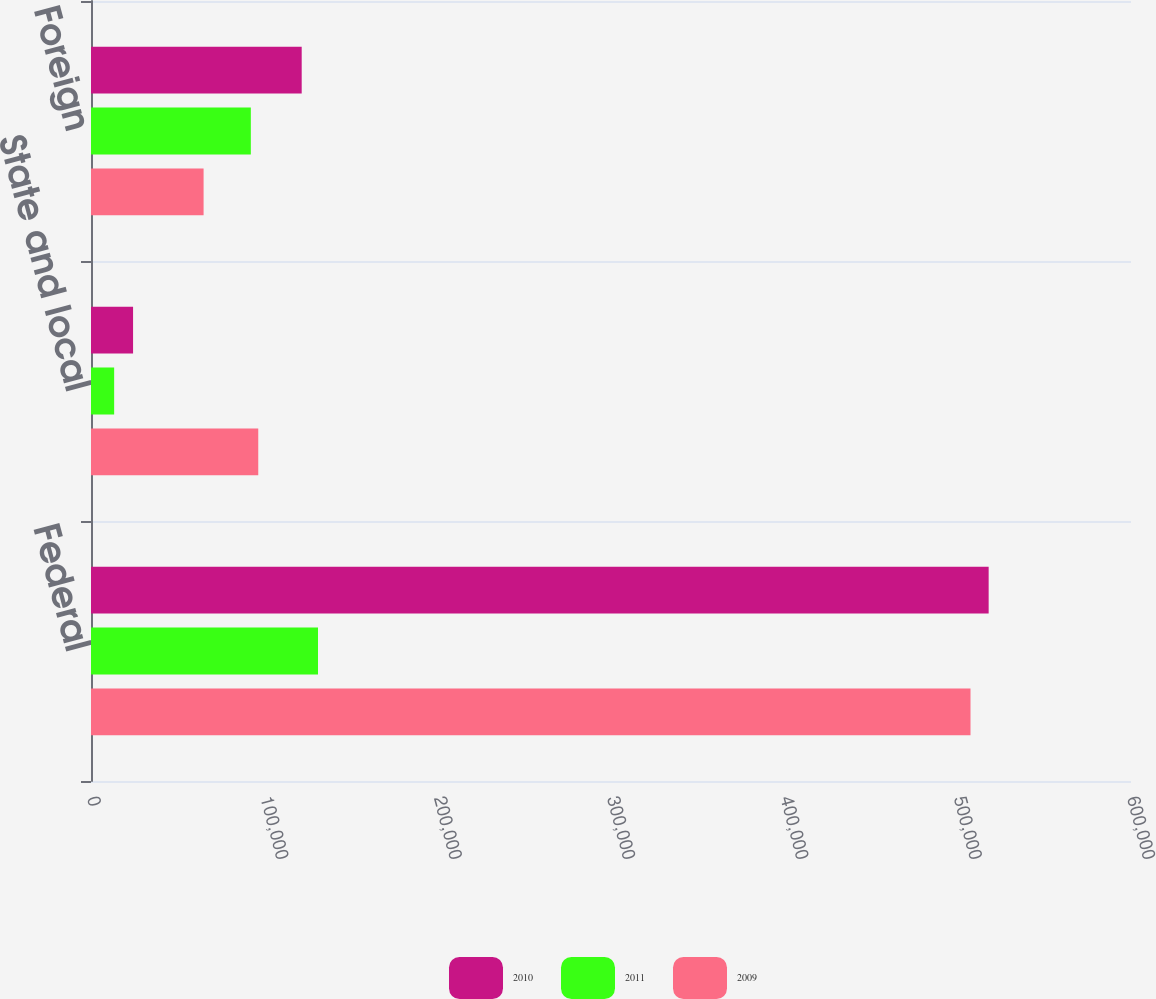<chart> <loc_0><loc_0><loc_500><loc_500><stacked_bar_chart><ecel><fcel>Federal<fcel>State and local<fcel>Foreign<nl><fcel>2010<fcel>517877<fcel>24268<fcel>121556<nl><fcel>2011<fcel>130962<fcel>13356<fcel>92209<nl><fcel>2009<fcel>507411<fcel>96496<fcel>64960<nl></chart> 